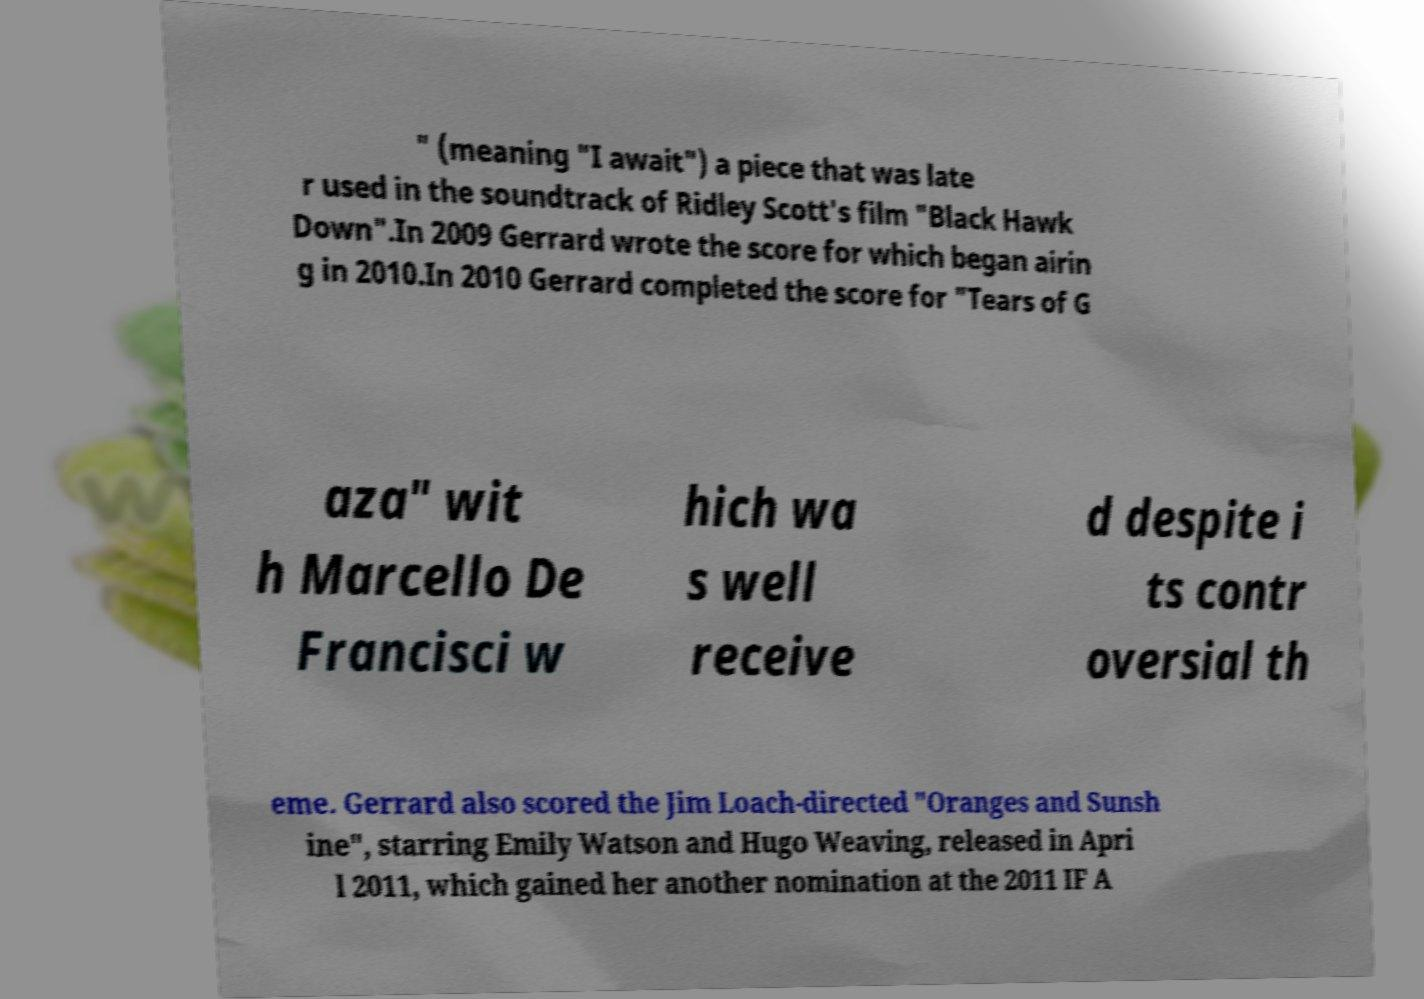For documentation purposes, I need the text within this image transcribed. Could you provide that? " (meaning "I await") a piece that was late r used in the soundtrack of Ridley Scott's film "Black Hawk Down".In 2009 Gerrard wrote the score for which began airin g in 2010.In 2010 Gerrard completed the score for "Tears of G aza" wit h Marcello De Francisci w hich wa s well receive d despite i ts contr oversial th eme. Gerrard also scored the Jim Loach-directed "Oranges and Sunsh ine", starring Emily Watson and Hugo Weaving, released in Apri l 2011, which gained her another nomination at the 2011 IF A 